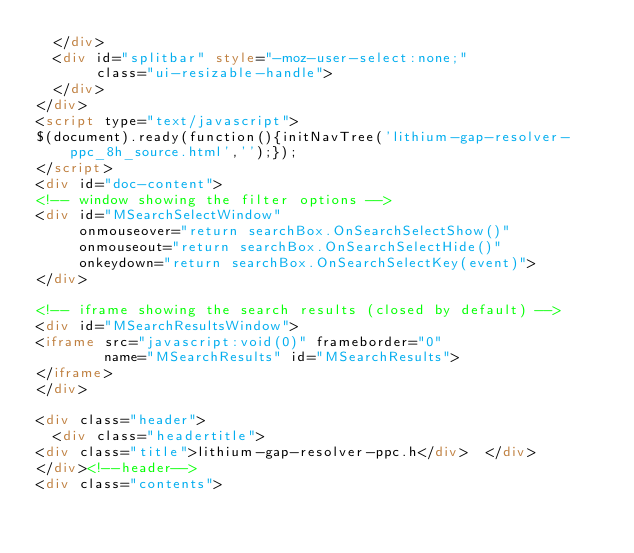Convert code to text. <code><loc_0><loc_0><loc_500><loc_500><_HTML_>  </div>
  <div id="splitbar" style="-moz-user-select:none;" 
       class="ui-resizable-handle">
  </div>
</div>
<script type="text/javascript">
$(document).ready(function(){initNavTree('lithium-gap-resolver-ppc_8h_source.html','');});
</script>
<div id="doc-content">
<!-- window showing the filter options -->
<div id="MSearchSelectWindow"
     onmouseover="return searchBox.OnSearchSelectShow()"
     onmouseout="return searchBox.OnSearchSelectHide()"
     onkeydown="return searchBox.OnSearchSelectKey(event)">
</div>

<!-- iframe showing the search results (closed by default) -->
<div id="MSearchResultsWindow">
<iframe src="javascript:void(0)" frameborder="0" 
        name="MSearchResults" id="MSearchResults">
</iframe>
</div>

<div class="header">
  <div class="headertitle">
<div class="title">lithium-gap-resolver-ppc.h</div>  </div>
</div><!--header-->
<div class="contents"></code> 